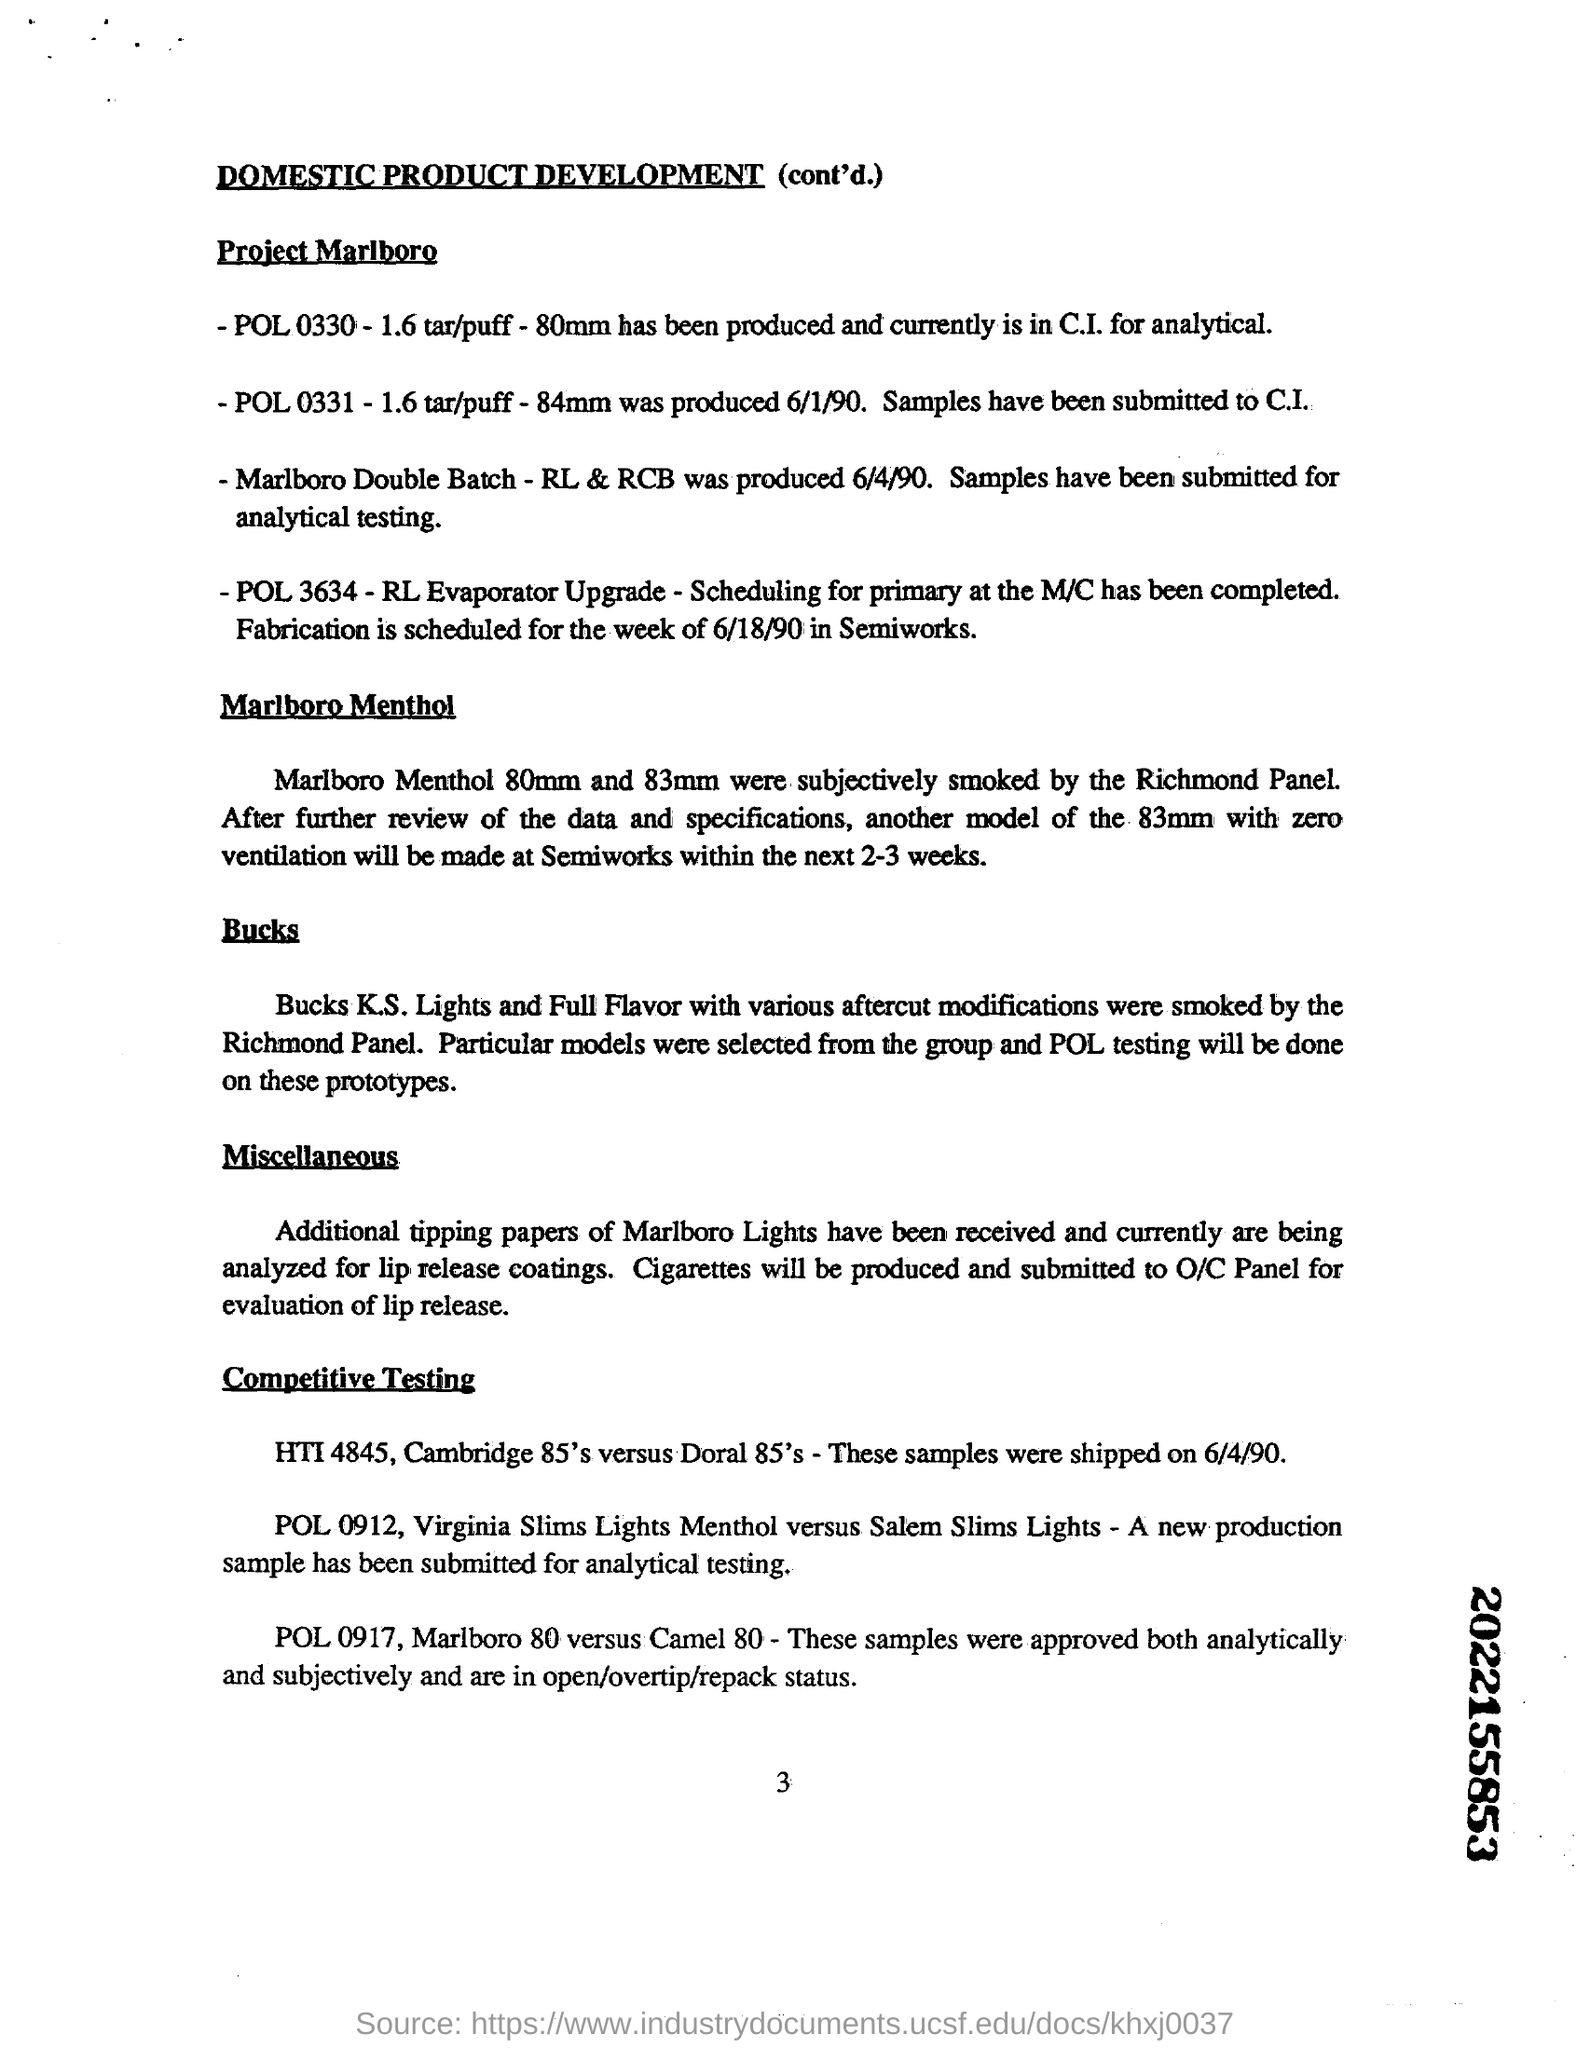what mm Marlboro Menthol were subjectively smoked by the Richmond Panel The Richmond Panel subjectively smoked Marlboro Menthol cigarettes in two sizes, specifically 80mm and 83mm. These tests helped evaluate the sensory impact and overall satisfaction from the different sizes to tailor the product more closely to consumer preferences. 